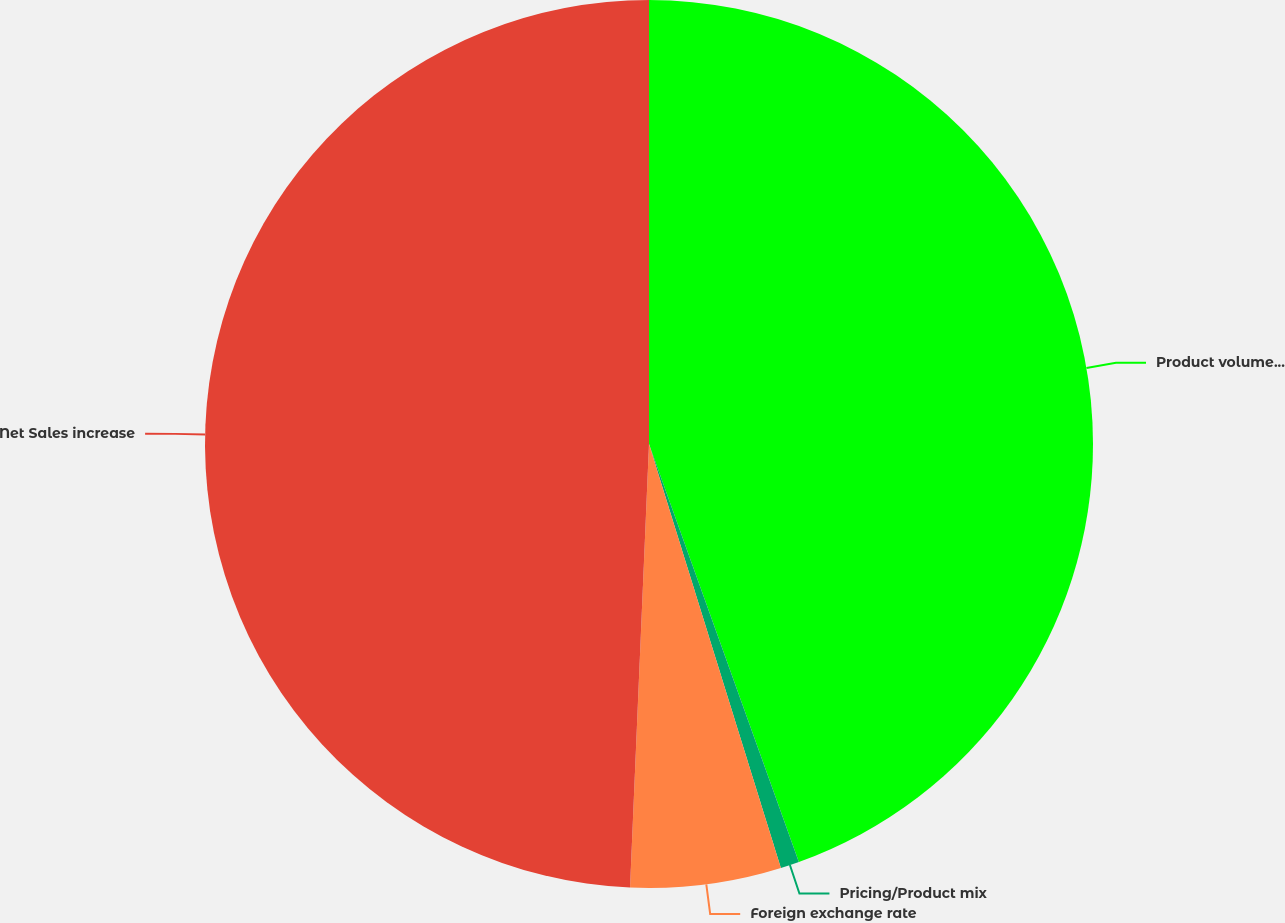Convert chart to OTSL. <chart><loc_0><loc_0><loc_500><loc_500><pie_chart><fcel>Product volumes sold<fcel>Pricing/Product mix<fcel>Foreign exchange rate<fcel>Net Sales increase<nl><fcel>44.52%<fcel>0.68%<fcel>5.48%<fcel>49.32%<nl></chart> 